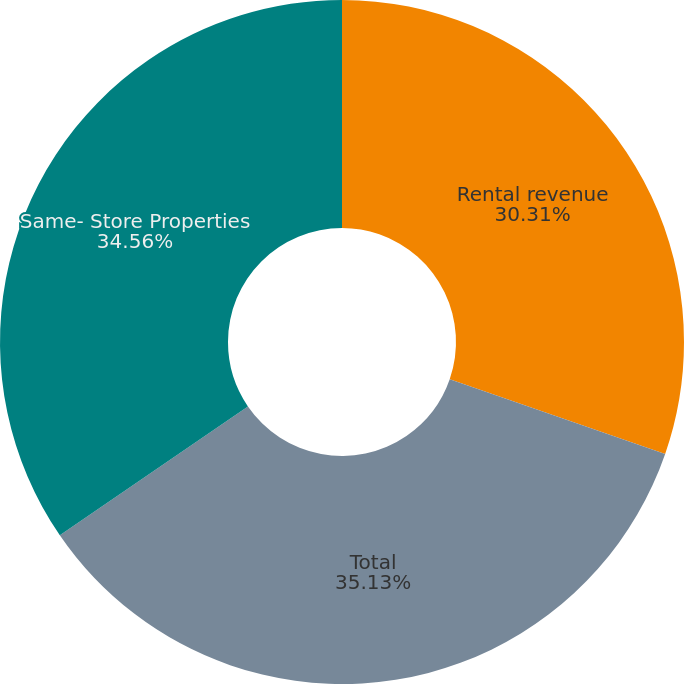Convert chart to OTSL. <chart><loc_0><loc_0><loc_500><loc_500><pie_chart><fcel>Rental revenue<fcel>Total<fcel>Same- Store Properties<nl><fcel>30.31%<fcel>35.14%<fcel>34.56%<nl></chart> 